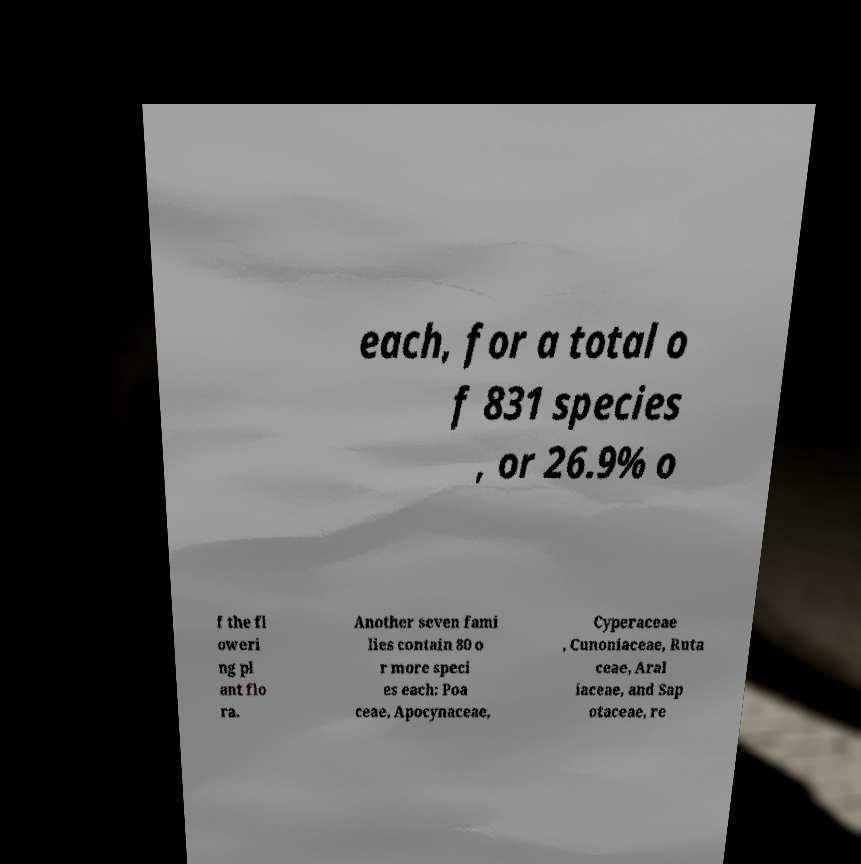Please read and relay the text visible in this image. What does it say? each, for a total o f 831 species , or 26.9% o f the fl oweri ng pl ant flo ra. Another seven fami lies contain 80 o r more speci es each: Poa ceae, Apocynaceae, Cyperaceae , Cunoniaceae, Ruta ceae, Aral iaceae, and Sap otaceae, re 